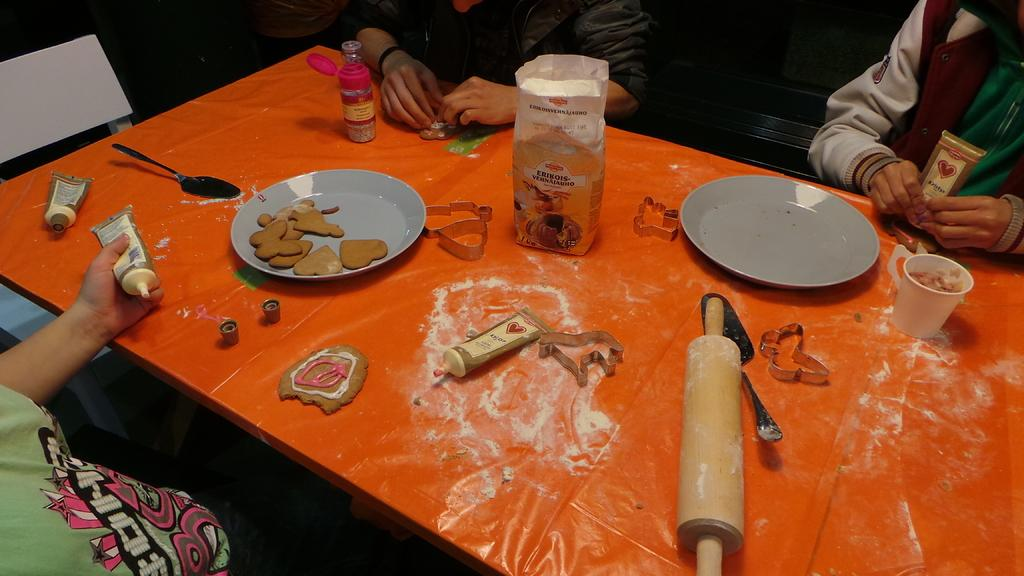How many people are in the image? There are three persons in the image. What are the persons doing in the image? The persons are sitting in front of a table. What can be seen on the table in the image? There are objects on the table. What type of boat can be seen in the image? There is no boat present in the image. How many wings are visible on the persons in the image? The persons in the image do not have wings, as they are human beings. 